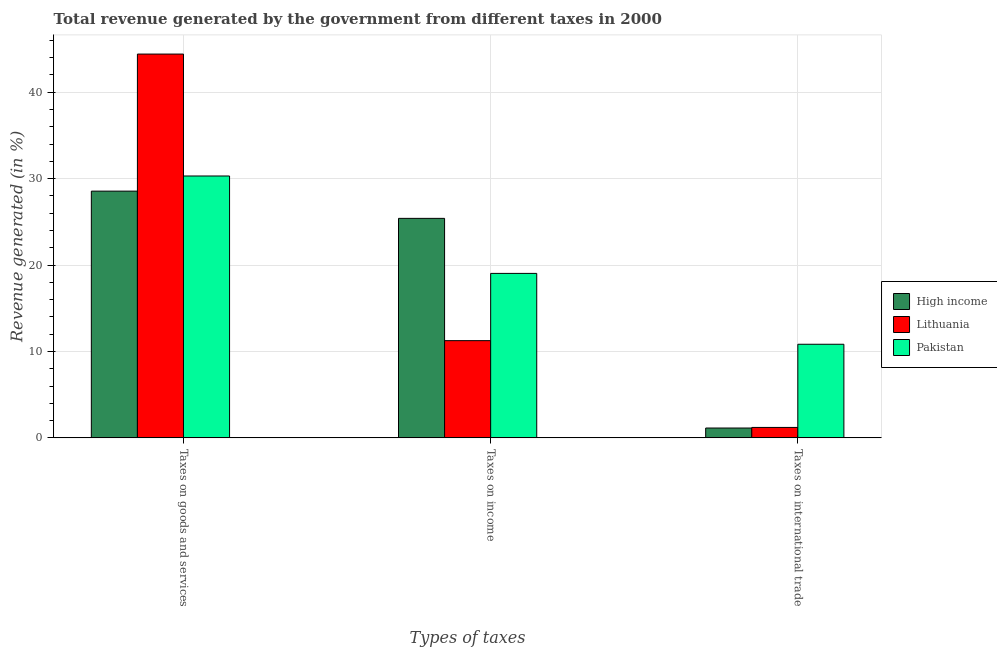How many different coloured bars are there?
Keep it short and to the point. 3. How many groups of bars are there?
Your response must be concise. 3. How many bars are there on the 3rd tick from the right?
Your response must be concise. 3. What is the label of the 1st group of bars from the left?
Make the answer very short. Taxes on goods and services. What is the percentage of revenue generated by taxes on goods and services in High income?
Provide a succinct answer. 28.55. Across all countries, what is the maximum percentage of revenue generated by tax on international trade?
Keep it short and to the point. 10.83. Across all countries, what is the minimum percentage of revenue generated by tax on international trade?
Keep it short and to the point. 1.14. In which country was the percentage of revenue generated by taxes on goods and services maximum?
Give a very brief answer. Lithuania. In which country was the percentage of revenue generated by taxes on income minimum?
Make the answer very short. Lithuania. What is the total percentage of revenue generated by taxes on income in the graph?
Your answer should be very brief. 55.68. What is the difference between the percentage of revenue generated by tax on international trade in Pakistan and that in Lithuania?
Your response must be concise. 9.62. What is the difference between the percentage of revenue generated by tax on international trade in High income and the percentage of revenue generated by taxes on goods and services in Lithuania?
Your response must be concise. -43.27. What is the average percentage of revenue generated by tax on international trade per country?
Provide a succinct answer. 4.39. What is the difference between the percentage of revenue generated by taxes on income and percentage of revenue generated by tax on international trade in Lithuania?
Provide a short and direct response. 10.04. In how many countries, is the percentage of revenue generated by tax on international trade greater than 38 %?
Your answer should be very brief. 0. What is the ratio of the percentage of revenue generated by tax on international trade in Lithuania to that in Pakistan?
Provide a short and direct response. 0.11. What is the difference between the highest and the second highest percentage of revenue generated by taxes on goods and services?
Offer a terse response. 14.11. What is the difference between the highest and the lowest percentage of revenue generated by tax on international trade?
Your answer should be very brief. 9.69. Is the sum of the percentage of revenue generated by taxes on income in High income and Lithuania greater than the maximum percentage of revenue generated by taxes on goods and services across all countries?
Give a very brief answer. No. What does the 3rd bar from the left in Taxes on goods and services represents?
Provide a short and direct response. Pakistan. How many bars are there?
Provide a succinct answer. 9. Are all the bars in the graph horizontal?
Your response must be concise. No. How many countries are there in the graph?
Offer a terse response. 3. Does the graph contain grids?
Offer a terse response. Yes. How are the legend labels stacked?
Your answer should be compact. Vertical. What is the title of the graph?
Your answer should be very brief. Total revenue generated by the government from different taxes in 2000. What is the label or title of the X-axis?
Provide a succinct answer. Types of taxes. What is the label or title of the Y-axis?
Your answer should be very brief. Revenue generated (in %). What is the Revenue generated (in %) in High income in Taxes on goods and services?
Give a very brief answer. 28.55. What is the Revenue generated (in %) in Lithuania in Taxes on goods and services?
Your response must be concise. 44.41. What is the Revenue generated (in %) in Pakistan in Taxes on goods and services?
Provide a succinct answer. 30.3. What is the Revenue generated (in %) of High income in Taxes on income?
Keep it short and to the point. 25.4. What is the Revenue generated (in %) of Lithuania in Taxes on income?
Keep it short and to the point. 11.25. What is the Revenue generated (in %) in Pakistan in Taxes on income?
Your answer should be very brief. 19.03. What is the Revenue generated (in %) of High income in Taxes on international trade?
Your answer should be very brief. 1.14. What is the Revenue generated (in %) of Lithuania in Taxes on international trade?
Offer a terse response. 1.21. What is the Revenue generated (in %) of Pakistan in Taxes on international trade?
Make the answer very short. 10.83. Across all Types of taxes, what is the maximum Revenue generated (in %) of High income?
Give a very brief answer. 28.55. Across all Types of taxes, what is the maximum Revenue generated (in %) of Lithuania?
Offer a very short reply. 44.41. Across all Types of taxes, what is the maximum Revenue generated (in %) of Pakistan?
Your response must be concise. 30.3. Across all Types of taxes, what is the minimum Revenue generated (in %) in High income?
Your response must be concise. 1.14. Across all Types of taxes, what is the minimum Revenue generated (in %) in Lithuania?
Provide a short and direct response. 1.21. Across all Types of taxes, what is the minimum Revenue generated (in %) in Pakistan?
Provide a succinct answer. 10.83. What is the total Revenue generated (in %) in High income in the graph?
Offer a very short reply. 55.09. What is the total Revenue generated (in %) of Lithuania in the graph?
Give a very brief answer. 56.87. What is the total Revenue generated (in %) of Pakistan in the graph?
Your response must be concise. 60.16. What is the difference between the Revenue generated (in %) of High income in Taxes on goods and services and that in Taxes on income?
Keep it short and to the point. 3.15. What is the difference between the Revenue generated (in %) in Lithuania in Taxes on goods and services and that in Taxes on income?
Your answer should be very brief. 33.16. What is the difference between the Revenue generated (in %) in Pakistan in Taxes on goods and services and that in Taxes on income?
Give a very brief answer. 11.27. What is the difference between the Revenue generated (in %) of High income in Taxes on goods and services and that in Taxes on international trade?
Keep it short and to the point. 27.41. What is the difference between the Revenue generated (in %) of Lithuania in Taxes on goods and services and that in Taxes on international trade?
Give a very brief answer. 43.2. What is the difference between the Revenue generated (in %) of Pakistan in Taxes on goods and services and that in Taxes on international trade?
Keep it short and to the point. 19.47. What is the difference between the Revenue generated (in %) in High income in Taxes on income and that in Taxes on international trade?
Keep it short and to the point. 24.26. What is the difference between the Revenue generated (in %) in Lithuania in Taxes on income and that in Taxes on international trade?
Keep it short and to the point. 10.04. What is the difference between the Revenue generated (in %) of Pakistan in Taxes on income and that in Taxes on international trade?
Keep it short and to the point. 8.2. What is the difference between the Revenue generated (in %) of High income in Taxes on goods and services and the Revenue generated (in %) of Lithuania in Taxes on income?
Your answer should be very brief. 17.3. What is the difference between the Revenue generated (in %) of High income in Taxes on goods and services and the Revenue generated (in %) of Pakistan in Taxes on income?
Provide a short and direct response. 9.52. What is the difference between the Revenue generated (in %) in Lithuania in Taxes on goods and services and the Revenue generated (in %) in Pakistan in Taxes on income?
Make the answer very short. 25.38. What is the difference between the Revenue generated (in %) of High income in Taxes on goods and services and the Revenue generated (in %) of Lithuania in Taxes on international trade?
Your answer should be compact. 27.34. What is the difference between the Revenue generated (in %) of High income in Taxes on goods and services and the Revenue generated (in %) of Pakistan in Taxes on international trade?
Keep it short and to the point. 17.72. What is the difference between the Revenue generated (in %) of Lithuania in Taxes on goods and services and the Revenue generated (in %) of Pakistan in Taxes on international trade?
Make the answer very short. 33.58. What is the difference between the Revenue generated (in %) in High income in Taxes on income and the Revenue generated (in %) in Lithuania in Taxes on international trade?
Provide a short and direct response. 24.19. What is the difference between the Revenue generated (in %) in High income in Taxes on income and the Revenue generated (in %) in Pakistan in Taxes on international trade?
Make the answer very short. 14.57. What is the difference between the Revenue generated (in %) of Lithuania in Taxes on income and the Revenue generated (in %) of Pakistan in Taxes on international trade?
Offer a very short reply. 0.42. What is the average Revenue generated (in %) of High income per Types of taxes?
Ensure brevity in your answer.  18.36. What is the average Revenue generated (in %) in Lithuania per Types of taxes?
Your answer should be compact. 18.96. What is the average Revenue generated (in %) of Pakistan per Types of taxes?
Keep it short and to the point. 20.05. What is the difference between the Revenue generated (in %) in High income and Revenue generated (in %) in Lithuania in Taxes on goods and services?
Provide a succinct answer. -15.86. What is the difference between the Revenue generated (in %) in High income and Revenue generated (in %) in Pakistan in Taxes on goods and services?
Keep it short and to the point. -1.75. What is the difference between the Revenue generated (in %) of Lithuania and Revenue generated (in %) of Pakistan in Taxes on goods and services?
Ensure brevity in your answer.  14.11. What is the difference between the Revenue generated (in %) in High income and Revenue generated (in %) in Lithuania in Taxes on income?
Provide a short and direct response. 14.15. What is the difference between the Revenue generated (in %) in High income and Revenue generated (in %) in Pakistan in Taxes on income?
Offer a terse response. 6.37. What is the difference between the Revenue generated (in %) of Lithuania and Revenue generated (in %) of Pakistan in Taxes on income?
Your response must be concise. -7.78. What is the difference between the Revenue generated (in %) in High income and Revenue generated (in %) in Lithuania in Taxes on international trade?
Offer a very short reply. -0.07. What is the difference between the Revenue generated (in %) of High income and Revenue generated (in %) of Pakistan in Taxes on international trade?
Offer a very short reply. -9.69. What is the difference between the Revenue generated (in %) of Lithuania and Revenue generated (in %) of Pakistan in Taxes on international trade?
Your response must be concise. -9.62. What is the ratio of the Revenue generated (in %) in High income in Taxes on goods and services to that in Taxes on income?
Make the answer very short. 1.12. What is the ratio of the Revenue generated (in %) in Lithuania in Taxes on goods and services to that in Taxes on income?
Provide a succinct answer. 3.95. What is the ratio of the Revenue generated (in %) in Pakistan in Taxes on goods and services to that in Taxes on income?
Offer a very short reply. 1.59. What is the ratio of the Revenue generated (in %) in High income in Taxes on goods and services to that in Taxes on international trade?
Offer a very short reply. 25.05. What is the ratio of the Revenue generated (in %) in Lithuania in Taxes on goods and services to that in Taxes on international trade?
Your answer should be very brief. 36.76. What is the ratio of the Revenue generated (in %) in Pakistan in Taxes on goods and services to that in Taxes on international trade?
Offer a terse response. 2.8. What is the ratio of the Revenue generated (in %) in High income in Taxes on income to that in Taxes on international trade?
Provide a short and direct response. 22.29. What is the ratio of the Revenue generated (in %) in Lithuania in Taxes on income to that in Taxes on international trade?
Make the answer very short. 9.31. What is the ratio of the Revenue generated (in %) in Pakistan in Taxes on income to that in Taxes on international trade?
Keep it short and to the point. 1.76. What is the difference between the highest and the second highest Revenue generated (in %) of High income?
Offer a very short reply. 3.15. What is the difference between the highest and the second highest Revenue generated (in %) of Lithuania?
Keep it short and to the point. 33.16. What is the difference between the highest and the second highest Revenue generated (in %) of Pakistan?
Your response must be concise. 11.27. What is the difference between the highest and the lowest Revenue generated (in %) of High income?
Your response must be concise. 27.41. What is the difference between the highest and the lowest Revenue generated (in %) in Lithuania?
Keep it short and to the point. 43.2. What is the difference between the highest and the lowest Revenue generated (in %) of Pakistan?
Give a very brief answer. 19.47. 